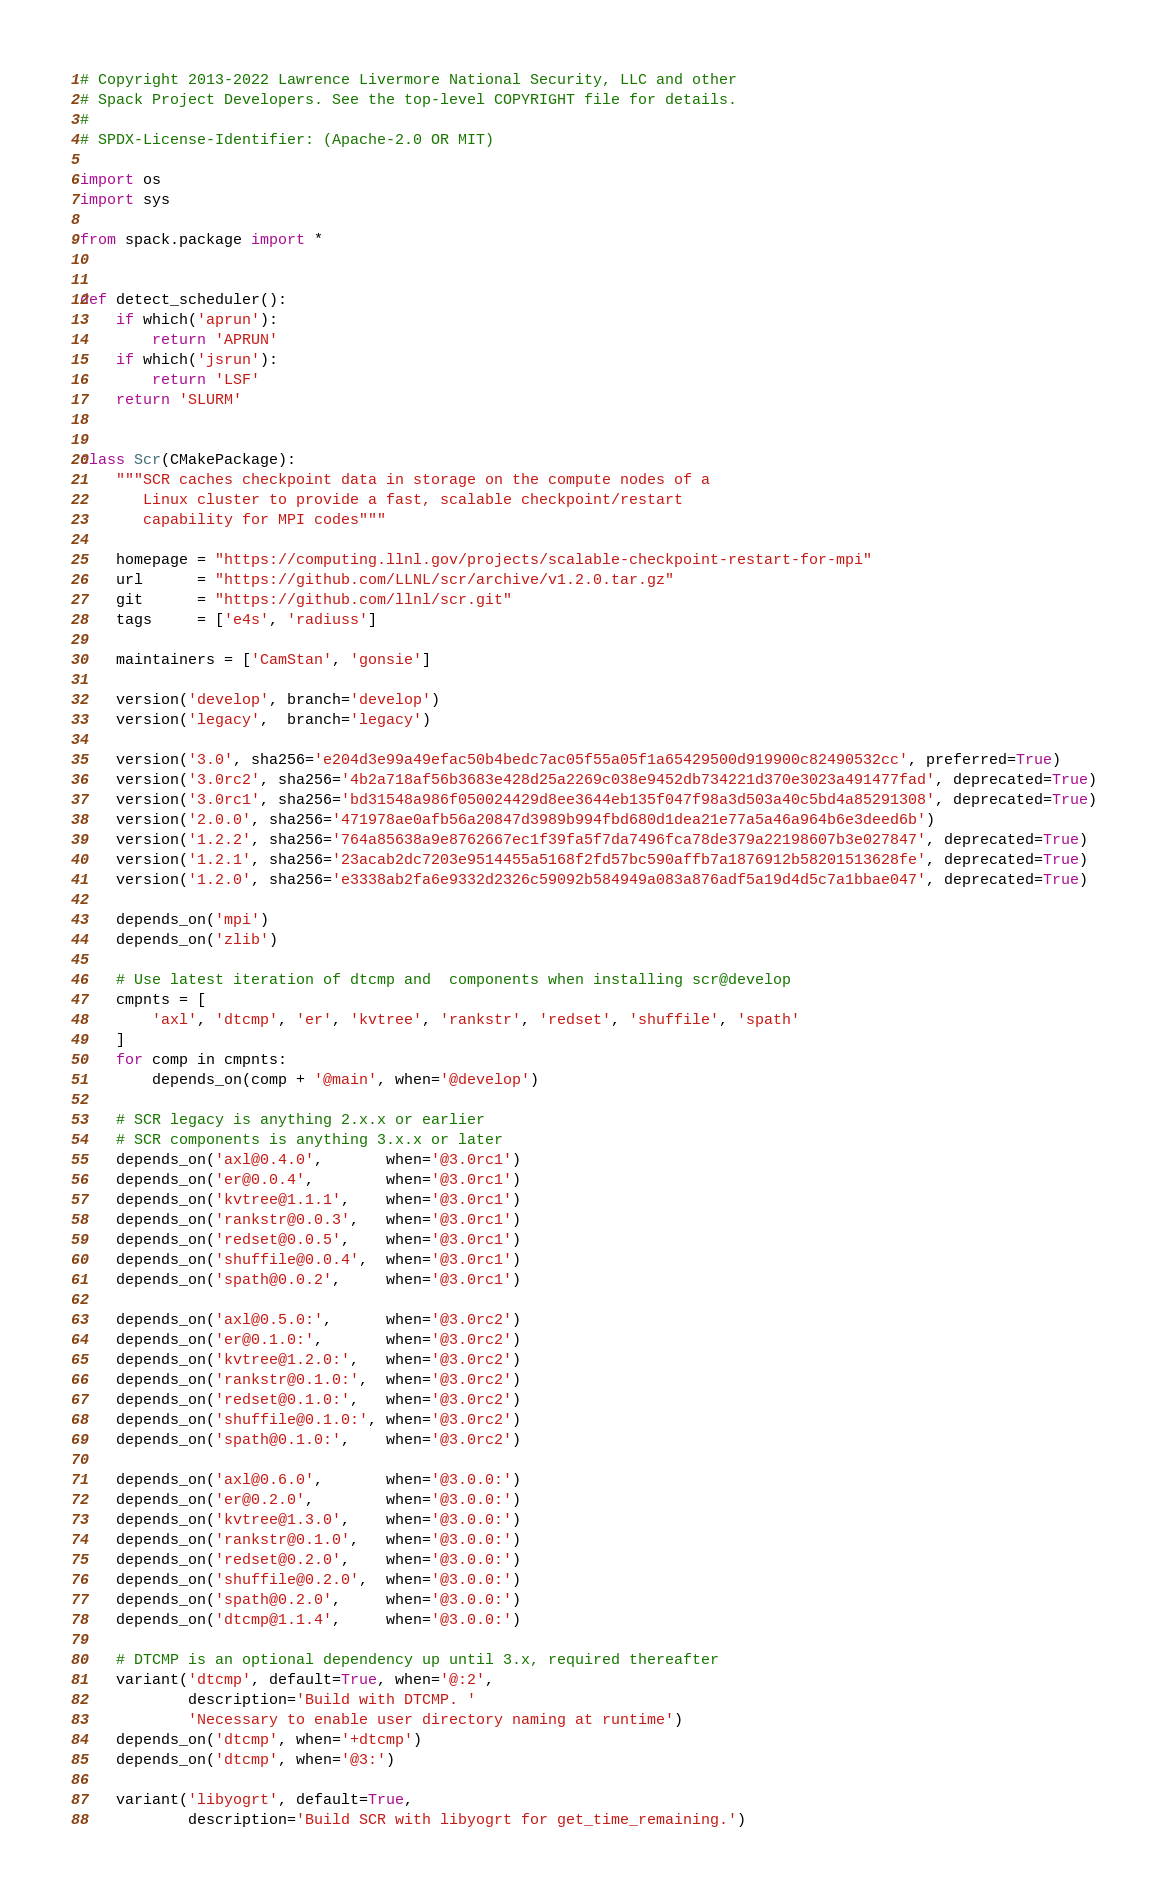Convert code to text. <code><loc_0><loc_0><loc_500><loc_500><_Python_># Copyright 2013-2022 Lawrence Livermore National Security, LLC and other
# Spack Project Developers. See the top-level COPYRIGHT file for details.
#
# SPDX-License-Identifier: (Apache-2.0 OR MIT)

import os
import sys

from spack.package import *


def detect_scheduler():
    if which('aprun'):
        return 'APRUN'
    if which('jsrun'):
        return 'LSF'
    return 'SLURM'


class Scr(CMakePackage):
    """SCR caches checkpoint data in storage on the compute nodes of a
       Linux cluster to provide a fast, scalable checkpoint/restart
       capability for MPI codes"""

    homepage = "https://computing.llnl.gov/projects/scalable-checkpoint-restart-for-mpi"
    url      = "https://github.com/LLNL/scr/archive/v1.2.0.tar.gz"
    git      = "https://github.com/llnl/scr.git"
    tags     = ['e4s', 'radiuss']

    maintainers = ['CamStan', 'gonsie']

    version('develop', branch='develop')
    version('legacy',  branch='legacy')

    version('3.0', sha256='e204d3e99a49efac50b4bedc7ac05f55a05f1a65429500d919900c82490532cc', preferred=True)
    version('3.0rc2', sha256='4b2a718af56b3683e428d25a2269c038e9452db734221d370e3023a491477fad', deprecated=True)
    version('3.0rc1', sha256='bd31548a986f050024429d8ee3644eb135f047f98a3d503a40c5bd4a85291308', deprecated=True)
    version('2.0.0', sha256='471978ae0afb56a20847d3989b994fbd680d1dea21e77a5a46a964b6e3deed6b')
    version('1.2.2', sha256='764a85638a9e8762667ec1f39fa5f7da7496fca78de379a22198607b3e027847', deprecated=True)
    version('1.2.1', sha256='23acab2dc7203e9514455a5168f2fd57bc590affb7a1876912b58201513628fe', deprecated=True)
    version('1.2.0', sha256='e3338ab2fa6e9332d2326c59092b584949a083a876adf5a19d4d5c7a1bbae047', deprecated=True)

    depends_on('mpi')
    depends_on('zlib')

    # Use latest iteration of dtcmp and  components when installing scr@develop
    cmpnts = [
        'axl', 'dtcmp', 'er', 'kvtree', 'rankstr', 'redset', 'shuffile', 'spath'
    ]
    for comp in cmpnts:
        depends_on(comp + '@main', when='@develop')

    # SCR legacy is anything 2.x.x or earlier
    # SCR components is anything 3.x.x or later
    depends_on('axl@0.4.0',       when='@3.0rc1')
    depends_on('er@0.0.4',        when='@3.0rc1')
    depends_on('kvtree@1.1.1',    when='@3.0rc1')
    depends_on('rankstr@0.0.3',   when='@3.0rc1')
    depends_on('redset@0.0.5',    when='@3.0rc1')
    depends_on('shuffile@0.0.4',  when='@3.0rc1')
    depends_on('spath@0.0.2',     when='@3.0rc1')

    depends_on('axl@0.5.0:',      when='@3.0rc2')
    depends_on('er@0.1.0:',       when='@3.0rc2')
    depends_on('kvtree@1.2.0:',   when='@3.0rc2')
    depends_on('rankstr@0.1.0:',  when='@3.0rc2')
    depends_on('redset@0.1.0:',   when='@3.0rc2')
    depends_on('shuffile@0.1.0:', when='@3.0rc2')
    depends_on('spath@0.1.0:',    when='@3.0rc2')

    depends_on('axl@0.6.0',       when='@3.0.0:')
    depends_on('er@0.2.0',        when='@3.0.0:')
    depends_on('kvtree@1.3.0',    when='@3.0.0:')
    depends_on('rankstr@0.1.0',   when='@3.0.0:')
    depends_on('redset@0.2.0',    when='@3.0.0:')
    depends_on('shuffile@0.2.0',  when='@3.0.0:')
    depends_on('spath@0.2.0',     when='@3.0.0:')
    depends_on('dtcmp@1.1.4',     when='@3.0.0:')

    # DTCMP is an optional dependency up until 3.x, required thereafter
    variant('dtcmp', default=True, when='@:2',
            description='Build with DTCMP. '
            'Necessary to enable user directory naming at runtime')
    depends_on('dtcmp', when='+dtcmp')
    depends_on('dtcmp', when='@3:')

    variant('libyogrt', default=True,
            description='Build SCR with libyogrt for get_time_remaining.')</code> 